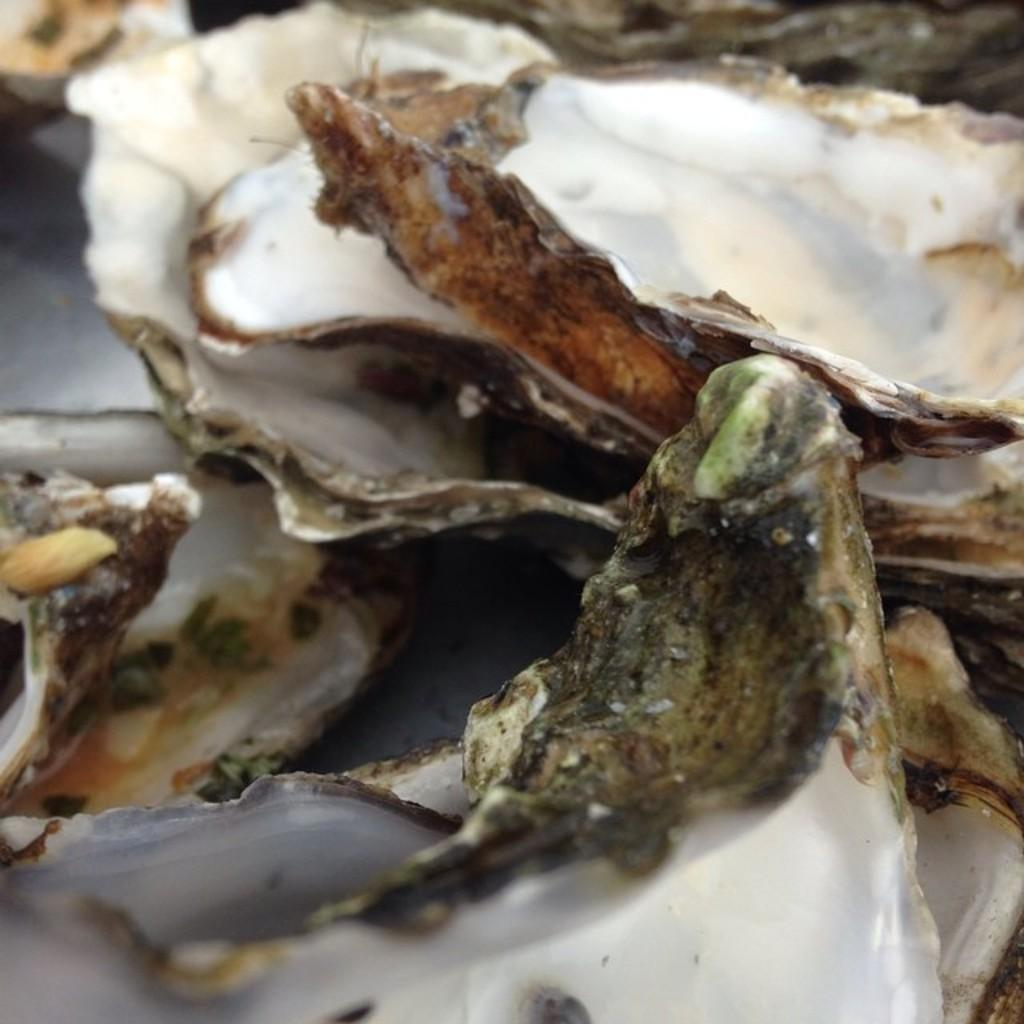What objects can be seen on the ground in the image? There are shells on the ground in the image. Can you describe the appearance of the shells? The shells have a unique shape and texture, likely from a marine organism. What might be the origin of these shells? The shells may have been brought to the location by the ocean or collected from a beach. What flavor does the creator of the shells prefer? The shells are not a food item and therefore have no flavor. Additionally, there is no information about a creator of the shells in the image. 